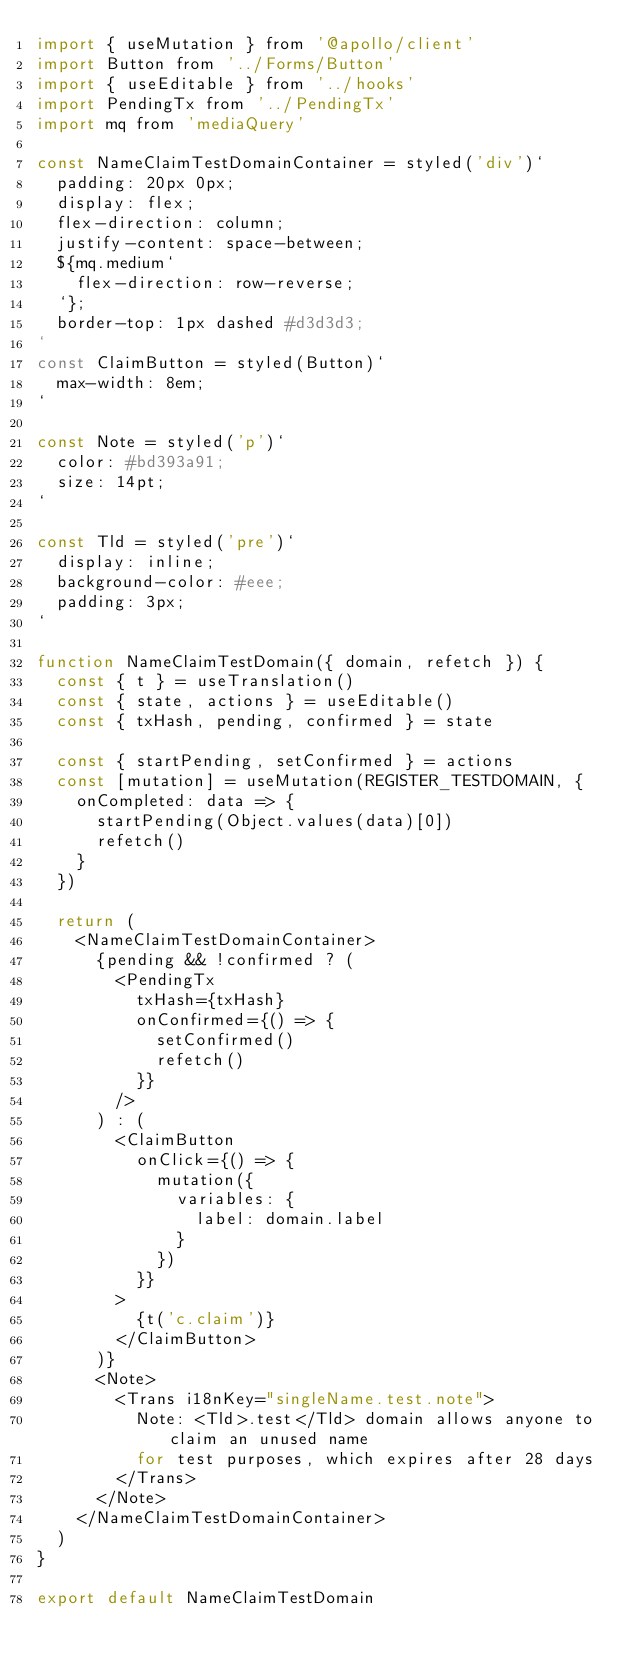<code> <loc_0><loc_0><loc_500><loc_500><_JavaScript_>import { useMutation } from '@apollo/client'
import Button from '../Forms/Button'
import { useEditable } from '../hooks'
import PendingTx from '../PendingTx'
import mq from 'mediaQuery'

const NameClaimTestDomainContainer = styled('div')`
  padding: 20px 0px;
  display: flex;
  flex-direction: column;
  justify-content: space-between;
  ${mq.medium`
    flex-direction: row-reverse;
  `};
  border-top: 1px dashed #d3d3d3;
`
const ClaimButton = styled(Button)`
  max-width: 8em;
`

const Note = styled('p')`
  color: #bd393a91;
  size: 14pt;
`

const Tld = styled('pre')`
  display: inline;
  background-color: #eee;
  padding: 3px;
`

function NameClaimTestDomain({ domain, refetch }) {
  const { t } = useTranslation()
  const { state, actions } = useEditable()
  const { txHash, pending, confirmed } = state

  const { startPending, setConfirmed } = actions
  const [mutation] = useMutation(REGISTER_TESTDOMAIN, {
    onCompleted: data => {
      startPending(Object.values(data)[0])
      refetch()
    }
  })

  return (
    <NameClaimTestDomainContainer>
      {pending && !confirmed ? (
        <PendingTx
          txHash={txHash}
          onConfirmed={() => {
            setConfirmed()
            refetch()
          }}
        />
      ) : (
        <ClaimButton
          onClick={() => {
            mutation({
              variables: {
                label: domain.label
              }
            })
          }}
        >
          {t('c.claim')}
        </ClaimButton>
      )}
      <Note>
        <Trans i18nKey="singleName.test.note">
          Note: <Tld>.test</Tld> domain allows anyone to claim an unused name
          for test purposes, which expires after 28 days
        </Trans>
      </Note>
    </NameClaimTestDomainContainer>
  )
}

export default NameClaimTestDomain
</code> 